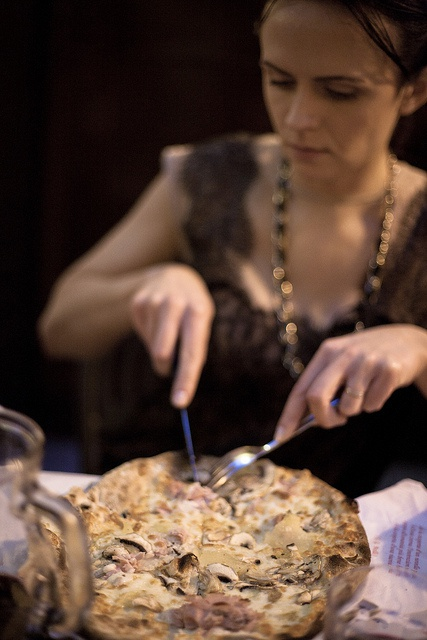Describe the objects in this image and their specific colors. I can see people in black, gray, brown, and maroon tones, pizza in black, gray, and tan tones, cup in black, gray, and tan tones, fork in black, gray, white, and maroon tones, and knife in black, navy, gray, and darkblue tones in this image. 